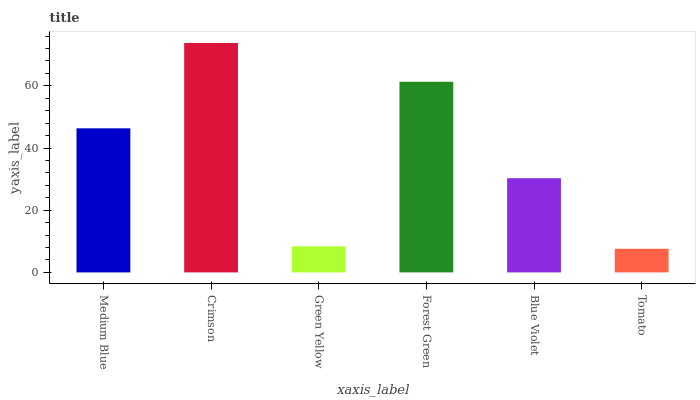Is Tomato the minimum?
Answer yes or no. Yes. Is Crimson the maximum?
Answer yes or no. Yes. Is Green Yellow the minimum?
Answer yes or no. No. Is Green Yellow the maximum?
Answer yes or no. No. Is Crimson greater than Green Yellow?
Answer yes or no. Yes. Is Green Yellow less than Crimson?
Answer yes or no. Yes. Is Green Yellow greater than Crimson?
Answer yes or no. No. Is Crimson less than Green Yellow?
Answer yes or no. No. Is Medium Blue the high median?
Answer yes or no. Yes. Is Blue Violet the low median?
Answer yes or no. Yes. Is Green Yellow the high median?
Answer yes or no. No. Is Tomato the low median?
Answer yes or no. No. 